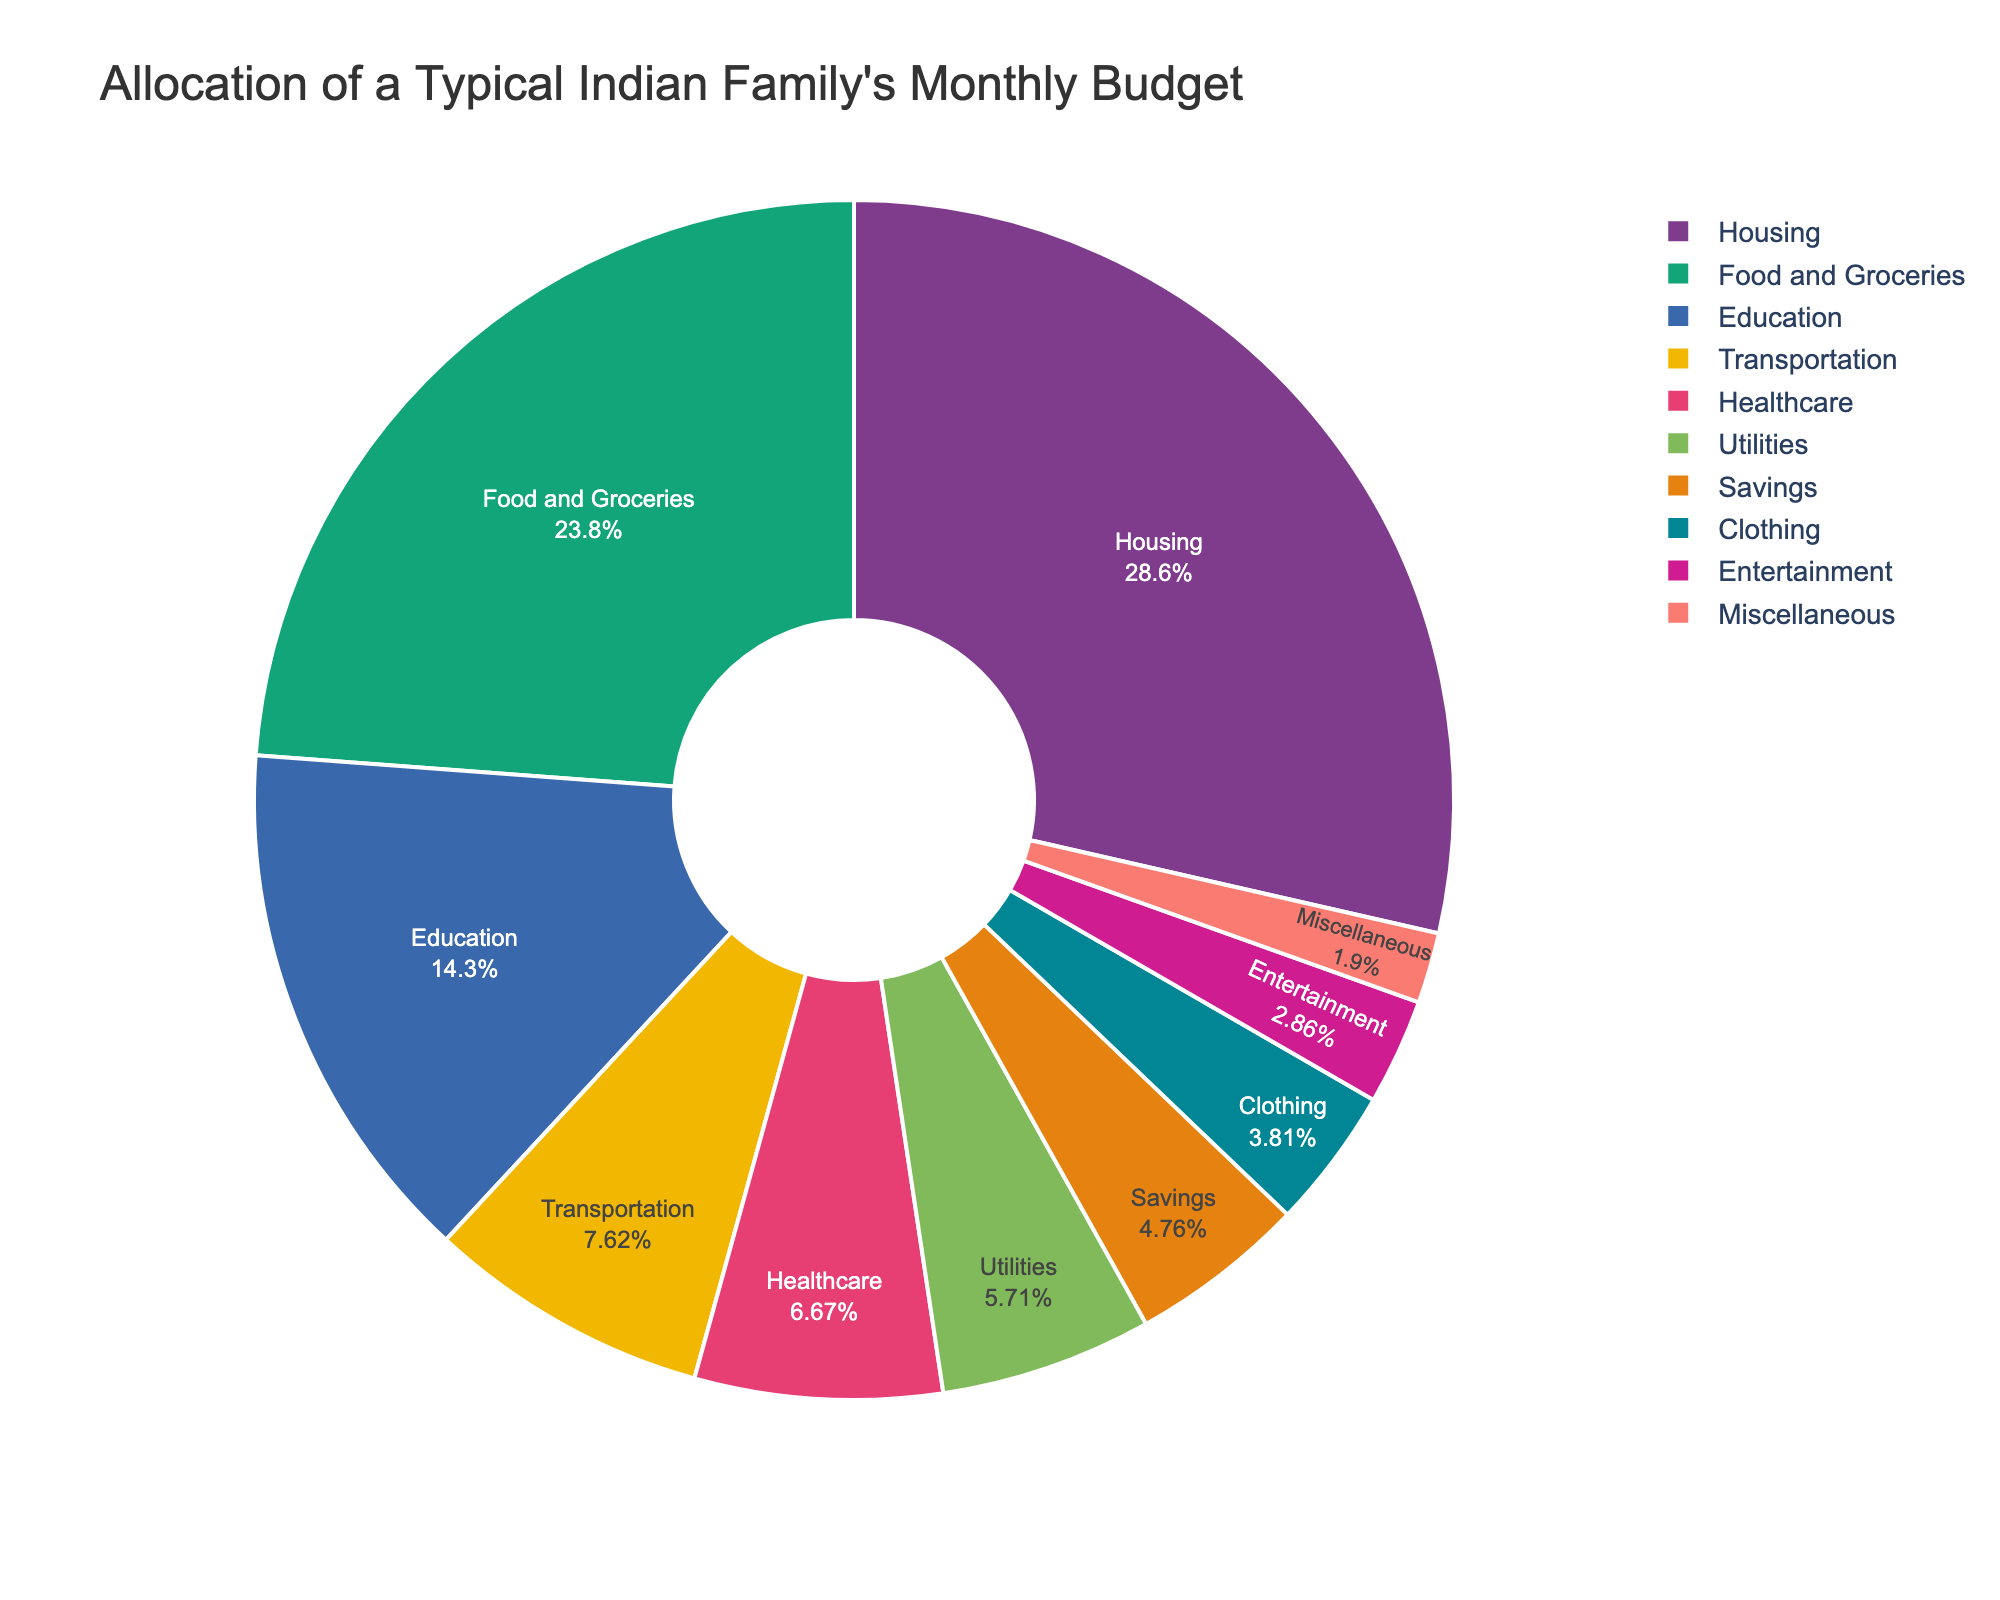What is the largest category in the budget allocation? The largest category in the pie chart occupies the biggest slice. The "Housing" category takes up this position on the chart, accounting for 30% of the budget.
Answer: Housing Which category takes up a smaller percentage: Transportation or Savings? Transportation accounts for 8% of the budget, while Savings account for 5%. Since 5% is less than 8%, Savings takes up a smaller percentage.
Answer: Savings What is the combined percentage allocation of Healthcare and Utilities? Healthcare is marked as 7% and Utilities are marked as 6% on the chart. Adding these two percentages together gives you 7% + 6% = 13%.
Answer: 13% Is the sum of categories Food and Groceries, and Education greater or less than Housing? Food and Groceries account for 25% and Education accounts for 15%, together summing to 25% + 15% = 40%. Housing, on the other hand, is 30%. Since 40% is greater than 30%, the combined categories are greater than Housing.
Answer: Greater How does the percentage allocation for Education compare to Healthcare? Education accounts for 15% whereas Healthcare accounts for 7%. Since 15% is more than 7%, Education has a higher percentage allocation than Healthcare.
Answer: Education has a higher percentage Rank the categories from highest to lowest in terms of percentage allocation. To rank the categories, you start by identifying the largest category and move downward: 
1. Housing (30%)
2. Food and Groceries (25%)
3. Education (15%)
4. Transportation (8%)
5. Healthcare (7%)
6. Utilities (6%)
7. Savings (5%)
8. Clothing (4%)
9. Entertainment (3%)
10. Miscellaneous (2%).
Answer: Housing, Food and Groceries, Education, Transportation, Healthcare, Utilities, Savings, Clothing, Entertainment, Miscellaneous What percentage of the budget is allocated to categories other than Housing, Food and Groceries, and Education? First, find the percentage for Housing (30%), Food and Groceries (25%), and Education (15%). Then sum these values: 30% + 25% + 15% = 70%. Subtract this from 100% to obtain the remaining budget allocation: 100% - 70% = 30%.
Answer: 30% Which categories together make up exactly 10% of the budget? Miscellaneous (2%) and Entertainment (3%) together make 5%, adding Clothing's 4% brings it to 9%, and Savings' 5% alone overshoots to 14%. So the category combinations examined do not add to exactly 10%.
Answer: None If the percentage allocated to Housing increases by 5%, what will be the new percentage? Current Housing allocation is 30%. Increasing this by 5% gives 30% + 5% = 35%.
Answer: 35% 